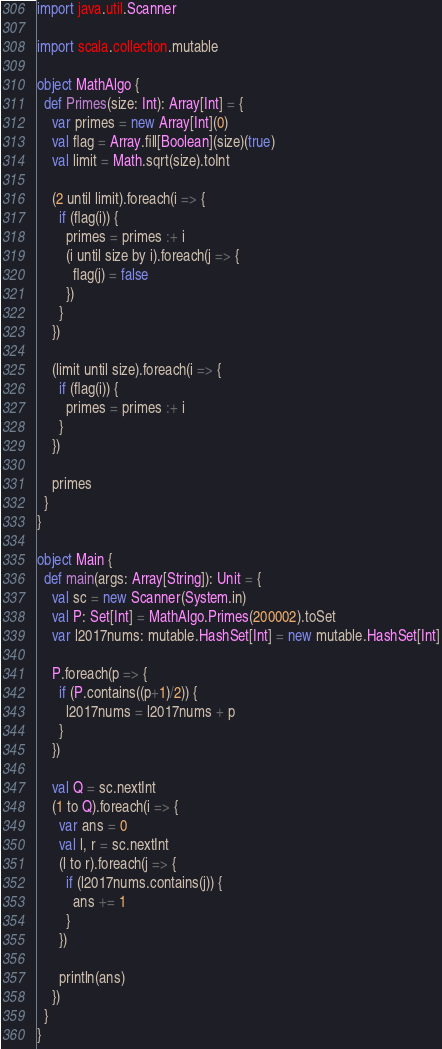<code> <loc_0><loc_0><loc_500><loc_500><_Scala_>import java.util.Scanner

import scala.collection.mutable

object MathAlgo {
  def Primes(size: Int): Array[Int] = {
    var primes = new Array[Int](0)
    val flag = Array.fill[Boolean](size)(true)
    val limit = Math.sqrt(size).toInt

    (2 until limit).foreach(i => {
      if (flag(i)) {
        primes = primes :+ i
        (i until size by i).foreach(j => {
          flag(j) = false
        })
      }
    })

    (limit until size).foreach(i => {
      if (flag(i)) {
        primes = primes :+ i
      }
    })

    primes
  }
}

object Main {
  def main(args: Array[String]): Unit = {
    val sc = new Scanner(System.in)
    val P: Set[Int] = MathAlgo.Primes(200002).toSet
    var l2017nums: mutable.HashSet[Int] = new mutable.HashSet[Int]

    P.foreach(p => {
      if (P.contains((p+1)/2)) {
        l2017nums = l2017nums + p
      }
    })

    val Q = sc.nextInt
    (1 to Q).foreach(i => {
      var ans = 0
      val l, r = sc.nextInt
      (l to r).foreach(j => {
        if (l2017nums.contains(j)) {
          ans += 1
        }
      })

      println(ans)
    })
  }
}</code> 